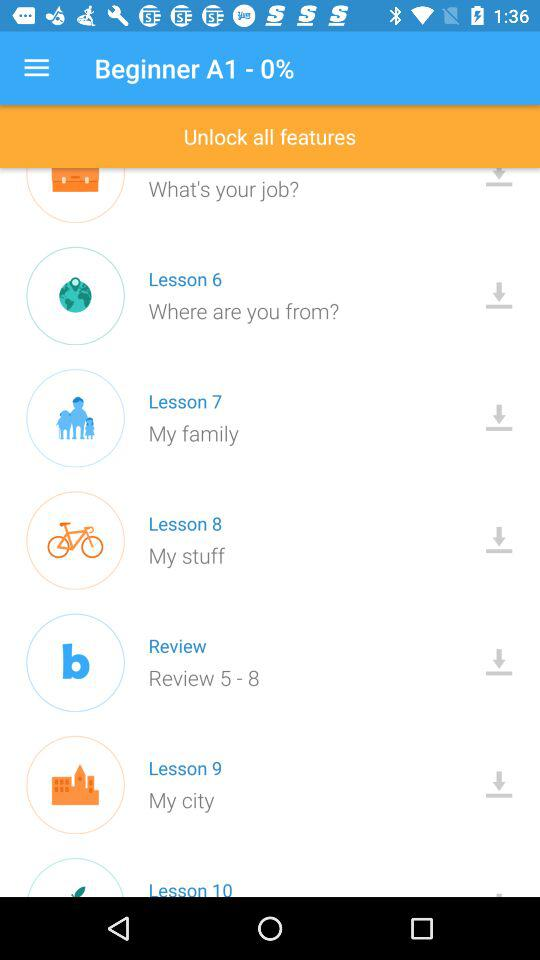Which lesson number is "My city"? "My city" is lesson number 9. 